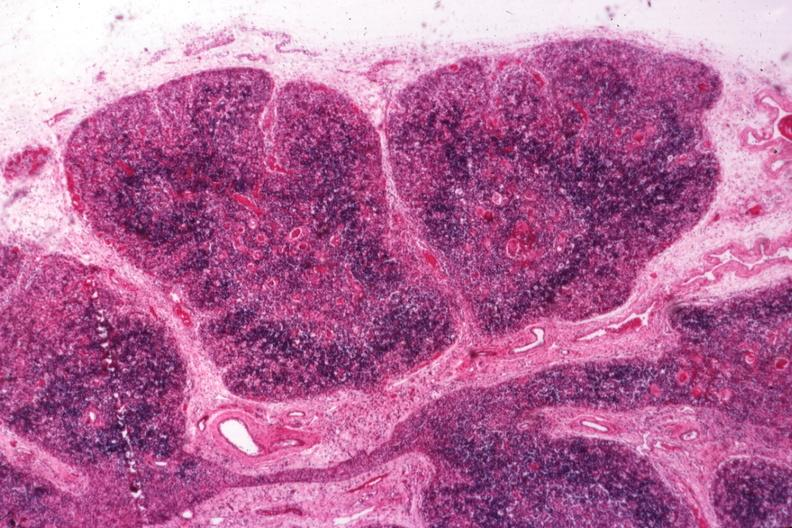what is typical atrophy associated?
Answer the question using a single word or phrase. With infection in newborn 